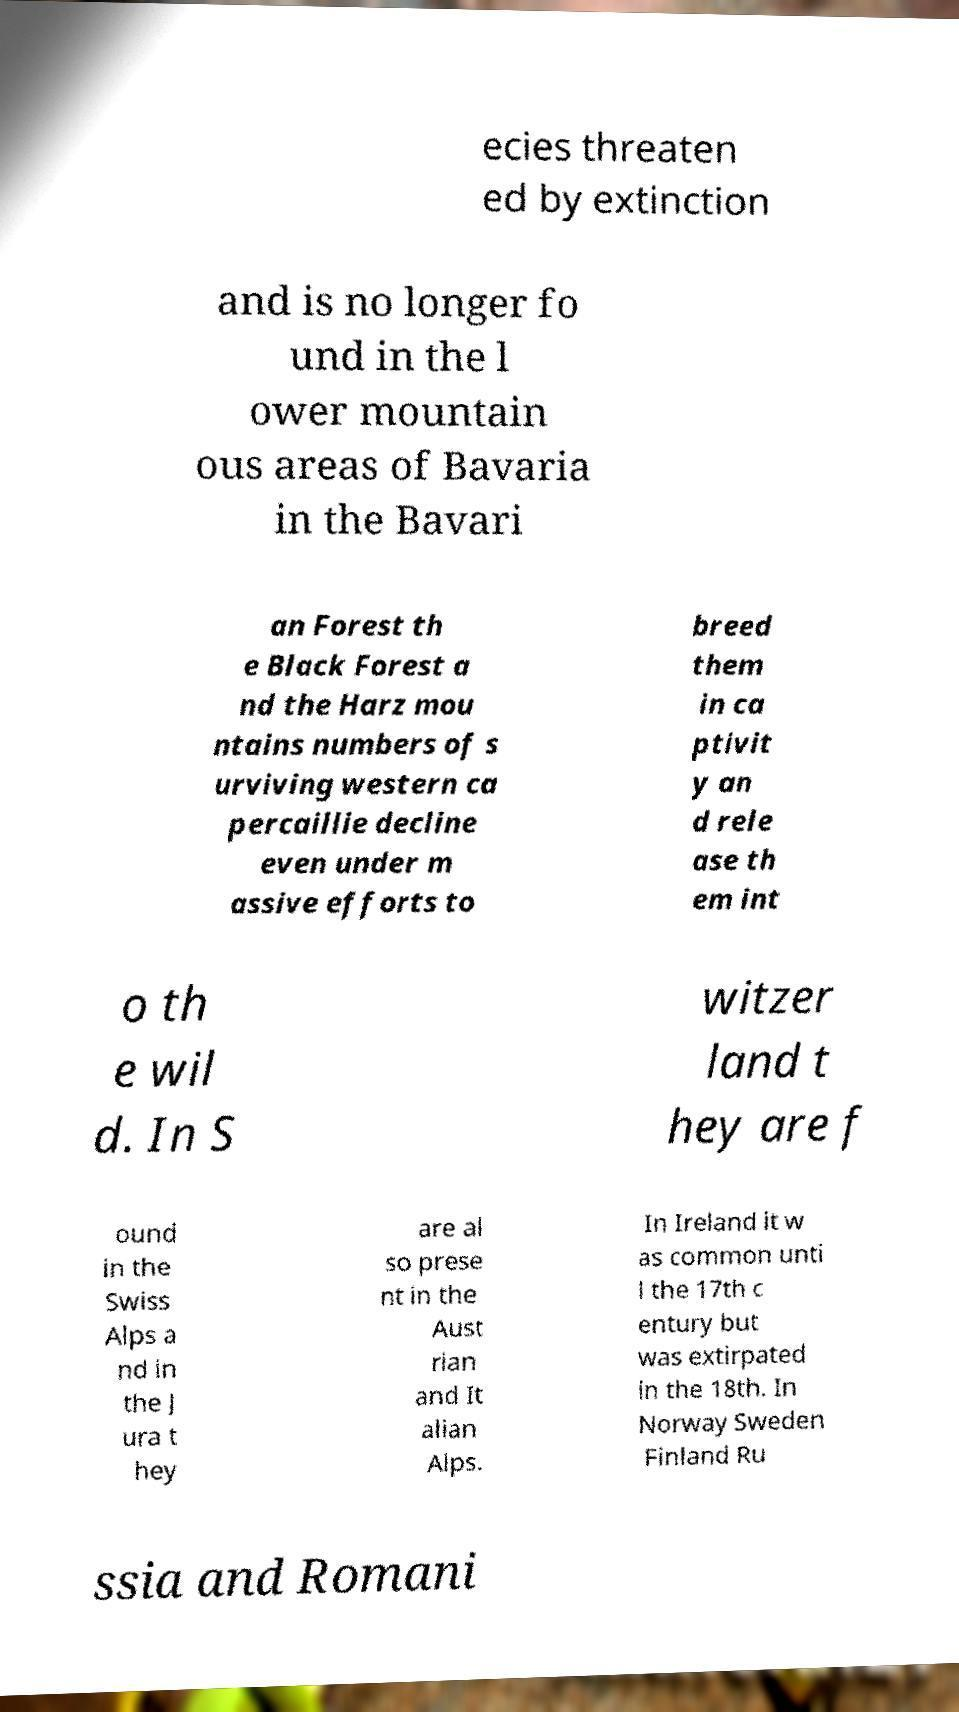Please identify and transcribe the text found in this image. ecies threaten ed by extinction and is no longer fo und in the l ower mountain ous areas of Bavaria in the Bavari an Forest th e Black Forest a nd the Harz mou ntains numbers of s urviving western ca percaillie decline even under m assive efforts to breed them in ca ptivit y an d rele ase th em int o th e wil d. In S witzer land t hey are f ound in the Swiss Alps a nd in the J ura t hey are al so prese nt in the Aust rian and It alian Alps. In Ireland it w as common unti l the 17th c entury but was extirpated in the 18th. In Norway Sweden Finland Ru ssia and Romani 